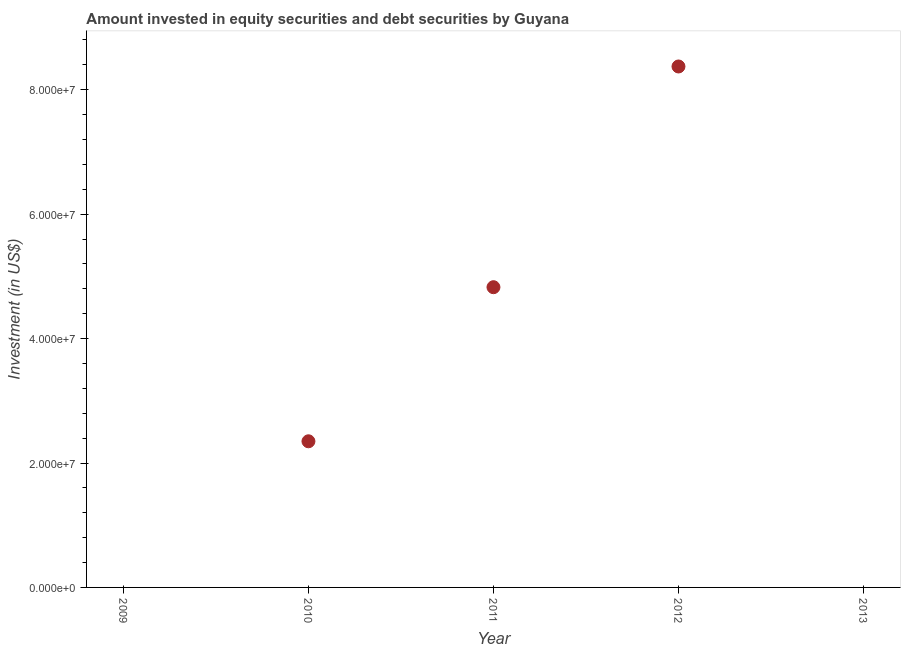What is the portfolio investment in 2012?
Offer a very short reply. 8.37e+07. Across all years, what is the maximum portfolio investment?
Your answer should be very brief. 8.37e+07. Across all years, what is the minimum portfolio investment?
Make the answer very short. 0. What is the sum of the portfolio investment?
Provide a short and direct response. 1.55e+08. What is the difference between the portfolio investment in 2011 and 2012?
Offer a very short reply. -3.55e+07. What is the average portfolio investment per year?
Give a very brief answer. 3.11e+07. What is the median portfolio investment?
Provide a succinct answer. 2.35e+07. In how many years, is the portfolio investment greater than 64000000 US$?
Keep it short and to the point. 1. What is the ratio of the portfolio investment in 2010 to that in 2011?
Provide a succinct answer. 0.49. What is the difference between the highest and the second highest portfolio investment?
Your answer should be very brief. 3.55e+07. Is the sum of the portfolio investment in 2010 and 2012 greater than the maximum portfolio investment across all years?
Your response must be concise. Yes. What is the difference between the highest and the lowest portfolio investment?
Make the answer very short. 8.37e+07. In how many years, is the portfolio investment greater than the average portfolio investment taken over all years?
Give a very brief answer. 2. Does the portfolio investment monotonically increase over the years?
Provide a short and direct response. No. What is the title of the graph?
Make the answer very short. Amount invested in equity securities and debt securities by Guyana. What is the label or title of the Y-axis?
Ensure brevity in your answer.  Investment (in US$). What is the Investment (in US$) in 2010?
Provide a short and direct response. 2.35e+07. What is the Investment (in US$) in 2011?
Give a very brief answer. 4.83e+07. What is the Investment (in US$) in 2012?
Your answer should be compact. 8.37e+07. What is the difference between the Investment (in US$) in 2010 and 2011?
Provide a short and direct response. -2.48e+07. What is the difference between the Investment (in US$) in 2010 and 2012?
Provide a short and direct response. -6.02e+07. What is the difference between the Investment (in US$) in 2011 and 2012?
Provide a succinct answer. -3.55e+07. What is the ratio of the Investment (in US$) in 2010 to that in 2011?
Make the answer very short. 0.49. What is the ratio of the Investment (in US$) in 2010 to that in 2012?
Provide a succinct answer. 0.28. What is the ratio of the Investment (in US$) in 2011 to that in 2012?
Provide a succinct answer. 0.58. 